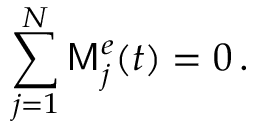<formula> <loc_0><loc_0><loc_500><loc_500>\sum _ { j = 1 } ^ { N } M _ { j } ^ { e } ( t ) = 0 \, .</formula> 